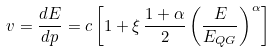<formula> <loc_0><loc_0><loc_500><loc_500>v = \frac { d E } { d p } = c \left [ 1 + \xi \, \frac { 1 + \alpha } { 2 } \left ( \frac { E } { E _ { Q G } } \right ) ^ { \alpha } \right ]</formula> 